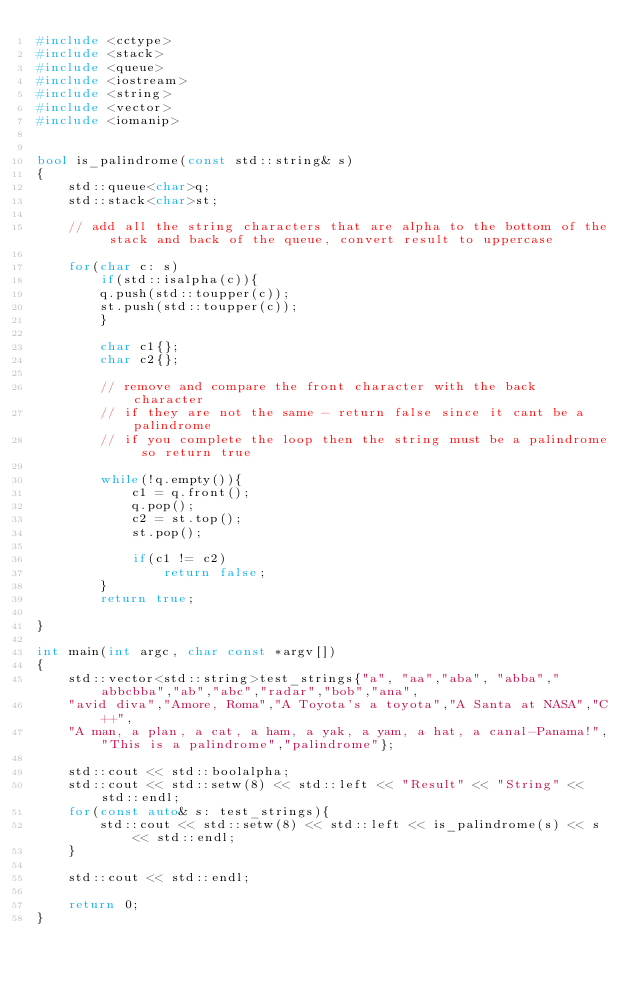Convert code to text. <code><loc_0><loc_0><loc_500><loc_500><_C++_>#include <cctype>
#include <stack>
#include <queue>
#include <iostream>
#include <string>
#include <vector>
#include <iomanip>


bool is_palindrome(const std::string& s)
{
    std::queue<char>q;
    std::stack<char>st;

    // add all the string characters that are alpha to the bottom of the stack and back of the queue, convert result to uppercase

    for(char c: s)
        if(std::isalpha(c)){
        q.push(std::toupper(c)); 
        st.push(std::toupper(c));
        }    

        char c1{};
        char c2{};

        // remove and compare the front character with the back character
        // if they are not the same - return false since it cant be a palindrome
        // if you complete the loop then the string must be a palindrome so return true

        while(!q.empty()){
            c1 = q.front();
            q.pop();
            c2 = st.top();
            st.pop();
            
            if(c1 != c2)
                return false;
        }
        return true;

}

int main(int argc, char const *argv[])
{
    std::vector<std::string>test_strings{"a", "aa","aba", "abba","abbcbba","ab","abc","radar","bob","ana",
    "avid diva","Amore, Roma","A Toyota's a toyota","A Santa at NASA","C++",
    "A man, a plan, a cat, a ham, a yak, a yam, a hat, a canal-Panama!","This is a palindrome","palindrome"};

    std::cout << std::boolalpha;
    std::cout << std::setw(8) << std::left << "Result" << "String" << std::endl;
    for(const auto& s: test_strings){
        std::cout << std::setw(8) << std::left << is_palindrome(s) << s << std::endl;
    }

    std::cout << std::endl;
    
    return 0;
}
</code> 